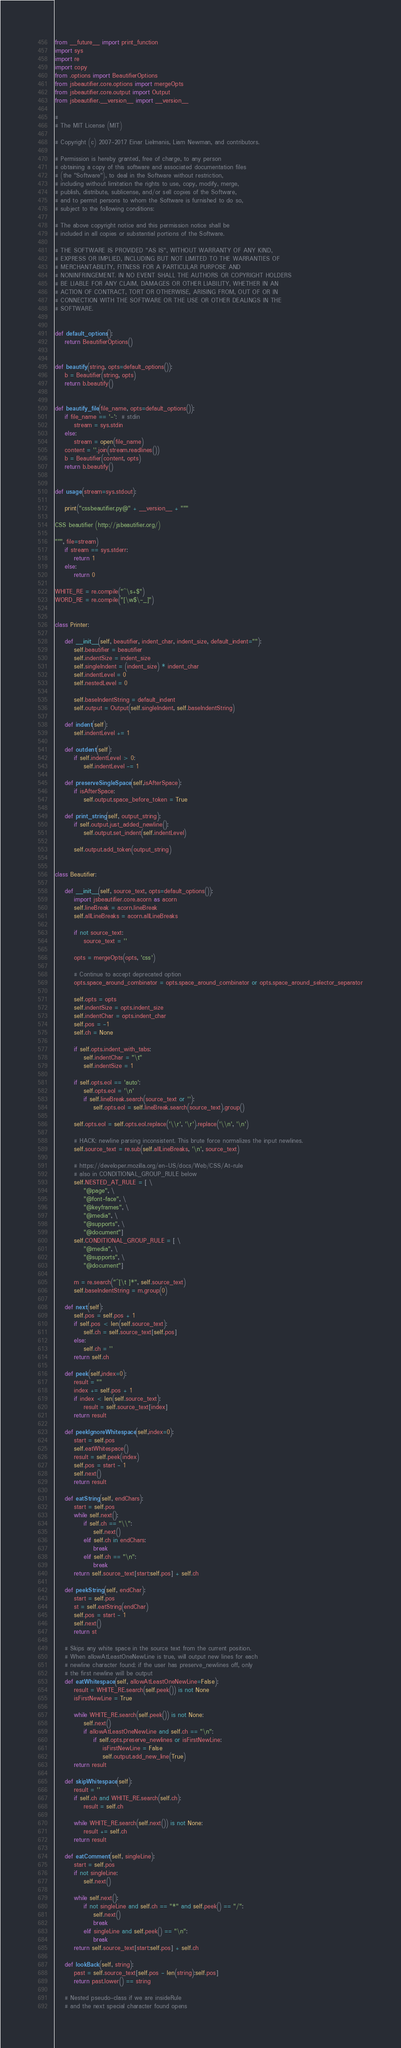<code> <loc_0><loc_0><loc_500><loc_500><_Python_>from __future__ import print_function
import sys
import re
import copy
from .options import BeautifierOptions
from jsbeautifier.core.options import mergeOpts
from jsbeautifier.core.output import Output
from jsbeautifier.__version__ import __version__

#
# The MIT License (MIT)

# Copyright (c) 2007-2017 Einar Lielmanis, Liam Newman, and contributors.

# Permission is hereby granted, free of charge, to any person
# obtaining a copy of this software and associated documentation files
# (the "Software"), to deal in the Software without restriction,
# including without limitation the rights to use, copy, modify, merge,
# publish, distribute, sublicense, and/or sell copies of the Software,
# and to permit persons to whom the Software is furnished to do so,
# subject to the following conditions:

# The above copyright notice and this permission notice shall be
# included in all copies or substantial portions of the Software.

# THE SOFTWARE IS PROVIDED "AS IS", WITHOUT WARRANTY OF ANY KIND,
# EXPRESS OR IMPLIED, INCLUDING BUT NOT LIMITED TO THE WARRANTIES OF
# MERCHANTABILITY, FITNESS FOR A PARTICULAR PURPOSE AND
# NONINFRINGEMENT. IN NO EVENT SHALL THE AUTHORS OR COPYRIGHT HOLDERS
# BE LIABLE FOR ANY CLAIM, DAMAGES OR OTHER LIABILITY, WHETHER IN AN
# ACTION OF CONTRACT, TORT OR OTHERWISE, ARISING FROM, OUT OF OR IN
# CONNECTION WITH THE SOFTWARE OR THE USE OR OTHER DEALINGS IN THE
# SOFTWARE.


def default_options():
    return BeautifierOptions()


def beautify(string, opts=default_options()):
    b = Beautifier(string, opts)
    return b.beautify()


def beautify_file(file_name, opts=default_options()):
    if file_name == '-':  # stdin
        stream = sys.stdin
    else:
        stream = open(file_name)
    content = ''.join(stream.readlines())
    b = Beautifier(content, opts)
    return b.beautify()


def usage(stream=sys.stdout):

    print("cssbeautifier.py@" + __version__ + """

CSS beautifier (http://jsbeautifier.org/)

""", file=stream)
    if stream == sys.stderr:
        return 1
    else:
        return 0

WHITE_RE = re.compile("^\s+$")
WORD_RE = re.compile("[\w$\-_]")


class Printer:

    def __init__(self, beautifier, indent_char, indent_size, default_indent=""):
        self.beautifier = beautifier
        self.indentSize = indent_size
        self.singleIndent = (indent_size) * indent_char
        self.indentLevel = 0
        self.nestedLevel = 0

        self.baseIndentString = default_indent
        self.output = Output(self.singleIndent, self.baseIndentString)

    def indent(self):
        self.indentLevel += 1

    def outdent(self):
        if self.indentLevel > 0:
            self.indentLevel -= 1

    def preserveSingleSpace(self,isAfterSpace):
        if isAfterSpace:
            self.output.space_before_token = True

    def print_string(self, output_string):
        if self.output.just_added_newline():
            self.output.set_indent(self.indentLevel)

        self.output.add_token(output_string)


class Beautifier:

    def __init__(self, source_text, opts=default_options()):
        import jsbeautifier.core.acorn as acorn
        self.lineBreak = acorn.lineBreak
        self.allLineBreaks = acorn.allLineBreaks

        if not source_text:
            source_text = ''

        opts = mergeOpts(opts, 'css')

        # Continue to accept deprecated option
        opts.space_around_combinator = opts.space_around_combinator or opts.space_around_selector_separator

        self.opts = opts
        self.indentSize = opts.indent_size
        self.indentChar = opts.indent_char
        self.pos = -1
        self.ch = None

        if self.opts.indent_with_tabs:
            self.indentChar = "\t"
            self.indentSize = 1

        if self.opts.eol == 'auto':
            self.opts.eol = '\n'
            if self.lineBreak.search(source_text or ''):
                self.opts.eol = self.lineBreak.search(source_text).group()

        self.opts.eol = self.opts.eol.replace('\\r', '\r').replace('\\n', '\n')

        # HACK: newline parsing inconsistent. This brute force normalizes the input newlines.
        self.source_text = re.sub(self.allLineBreaks, '\n', source_text)

        # https://developer.mozilla.org/en-US/docs/Web/CSS/At-rule
        # also in CONDITIONAL_GROUP_RULE below
        self.NESTED_AT_RULE = [ \
            "@page", \
            "@font-face", \
            "@keyframes", \
            "@media", \
            "@supports", \
            "@document"]
        self.CONDITIONAL_GROUP_RULE = [ \
            "@media", \
            "@supports", \
            "@document"]

        m = re.search("^[\t ]*", self.source_text)
        self.baseIndentString = m.group(0)

    def next(self):
        self.pos = self.pos + 1
        if self.pos < len(self.source_text):
            self.ch = self.source_text[self.pos]
        else:
            self.ch = ''
        return self.ch

    def peek(self,index=0):
        result = ""
        index += self.pos + 1
        if index < len(self.source_text):
            result = self.source_text[index]
        return result

    def peekIgnoreWhitespace(self,index=0):
        start = self.pos
        self.eatWhitespace()
        result = self.peek(index)
        self.pos = start - 1
        self.next()
        return result

    def eatString(self, endChars):
        start = self.pos
        while self.next():
            if self.ch == "\\":
                self.next()
            elif self.ch in endChars:
                break
            elif self.ch == "\n":
                break
        return self.source_text[start:self.pos] + self.ch

    def peekString(self, endChar):
        start = self.pos
        st = self.eatString(endChar)
        self.pos = start - 1
        self.next()
        return st

    # Skips any white space in the source text from the current position.
    # When allowAtLeastOneNewLine is true, will output new lines for each
    # newline character found; if the user has preserve_newlines off, only
    # the first newline will be output
    def eatWhitespace(self, allowAtLeastOneNewLine=False):
        result = WHITE_RE.search(self.peek()) is not None
        isFirstNewLine = True

        while WHITE_RE.search(self.peek()) is not None:
            self.next()
            if allowAtLeastOneNewLine and self.ch == "\n":
                if self.opts.preserve_newlines or isFirstNewLine:
                    isFirstNewLine = False
                    self.output.add_new_line(True)
        return result

    def skipWhitespace(self):
        result = ''
        if self.ch and WHITE_RE.search(self.ch):
            result = self.ch

        while WHITE_RE.search(self.next()) is not None:
            result += self.ch
        return result

    def eatComment(self, singleLine):
        start = self.pos
        if not singleLine:
            self.next()

        while self.next():
            if not singleLine and self.ch == "*" and self.peek() == "/":
                self.next()
                break
            elif singleLine and self.peek() == "\n":
                break
        return self.source_text[start:self.pos] + self.ch

    def lookBack(self, string):
        past = self.source_text[self.pos - len(string):self.pos]
        return past.lower() == string

    # Nested pseudo-class if we are insideRule
    # and the next special character found opens</code> 